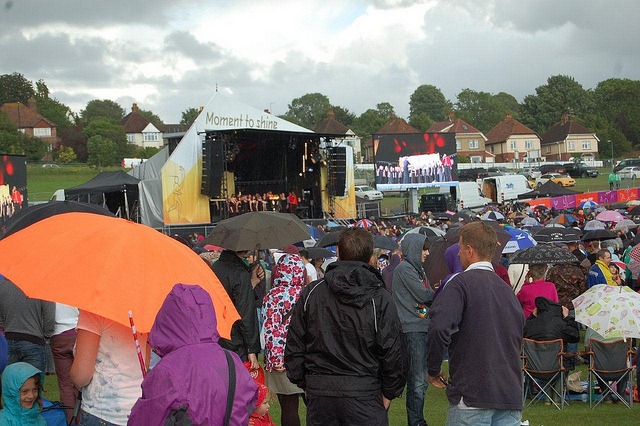Please extract the text content from this image. Moment TO shine 